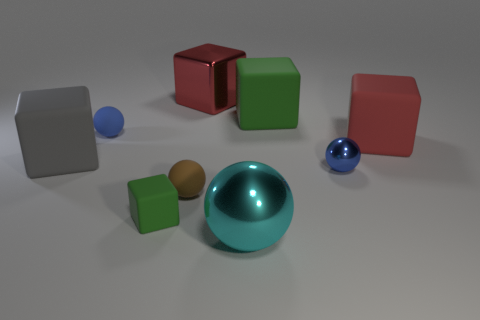There is a tiny sphere that is made of the same material as the big cyan ball; what color is it? The tiny sphere shares the same material and color as the larger cyan ball. Its color is a shade of light blue with a glossy finish, reflecting the environment around it much like the larger cyan sphere. 